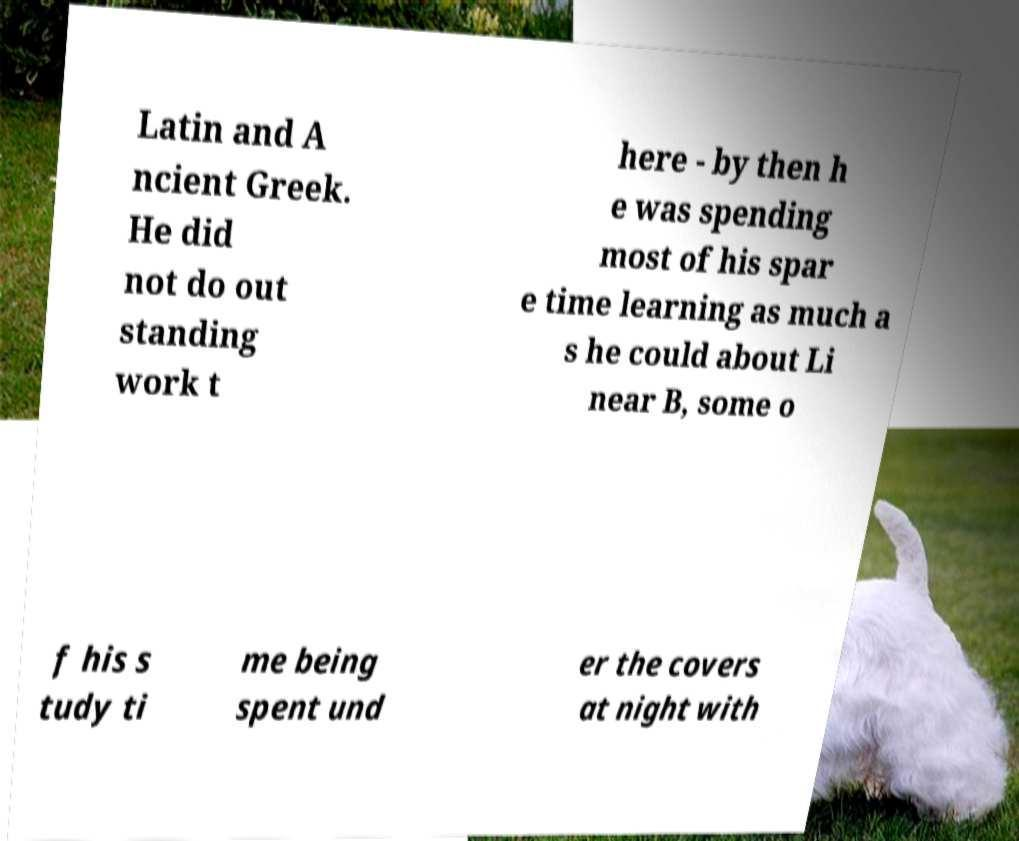Can you read and provide the text displayed in the image?This photo seems to have some interesting text. Can you extract and type it out for me? Latin and A ncient Greek. He did not do out standing work t here - by then h e was spending most of his spar e time learning as much a s he could about Li near B, some o f his s tudy ti me being spent und er the covers at night with 